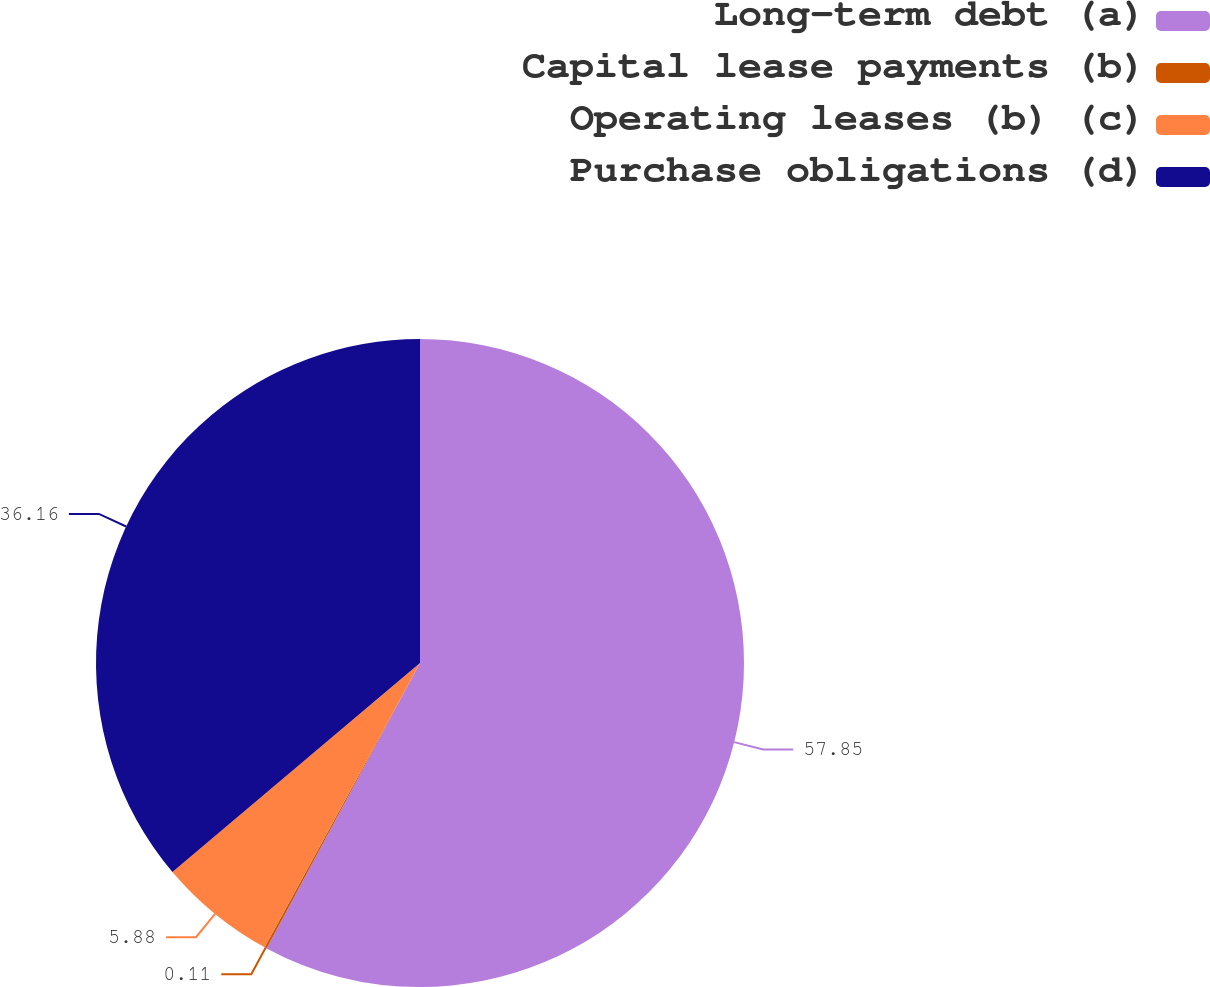<chart> <loc_0><loc_0><loc_500><loc_500><pie_chart><fcel>Long-term debt (a)<fcel>Capital lease payments (b)<fcel>Operating leases (b) (c)<fcel>Purchase obligations (d)<nl><fcel>57.85%<fcel>0.11%<fcel>5.88%<fcel>36.16%<nl></chart> 